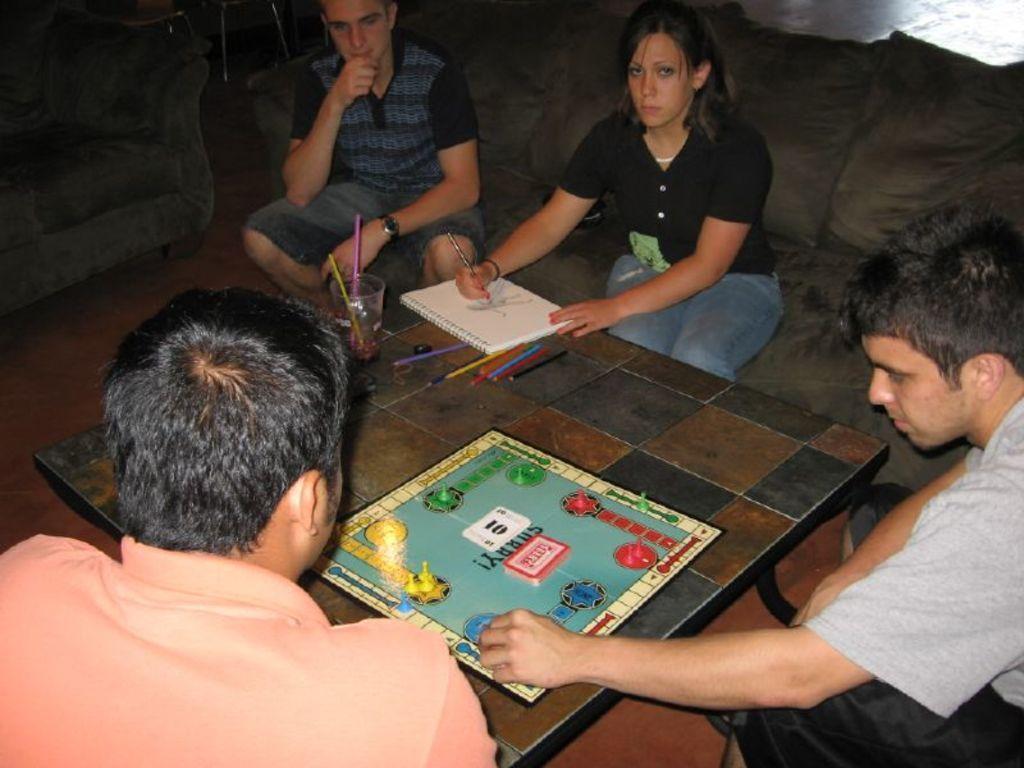How would you summarize this image in a sentence or two? Here we can see four persons sitting on sofas in front of a table and on the table we can see pencils and a glass. Here we can see this two men playing a game and this woman is drawing by holding a pencil in her hand. 